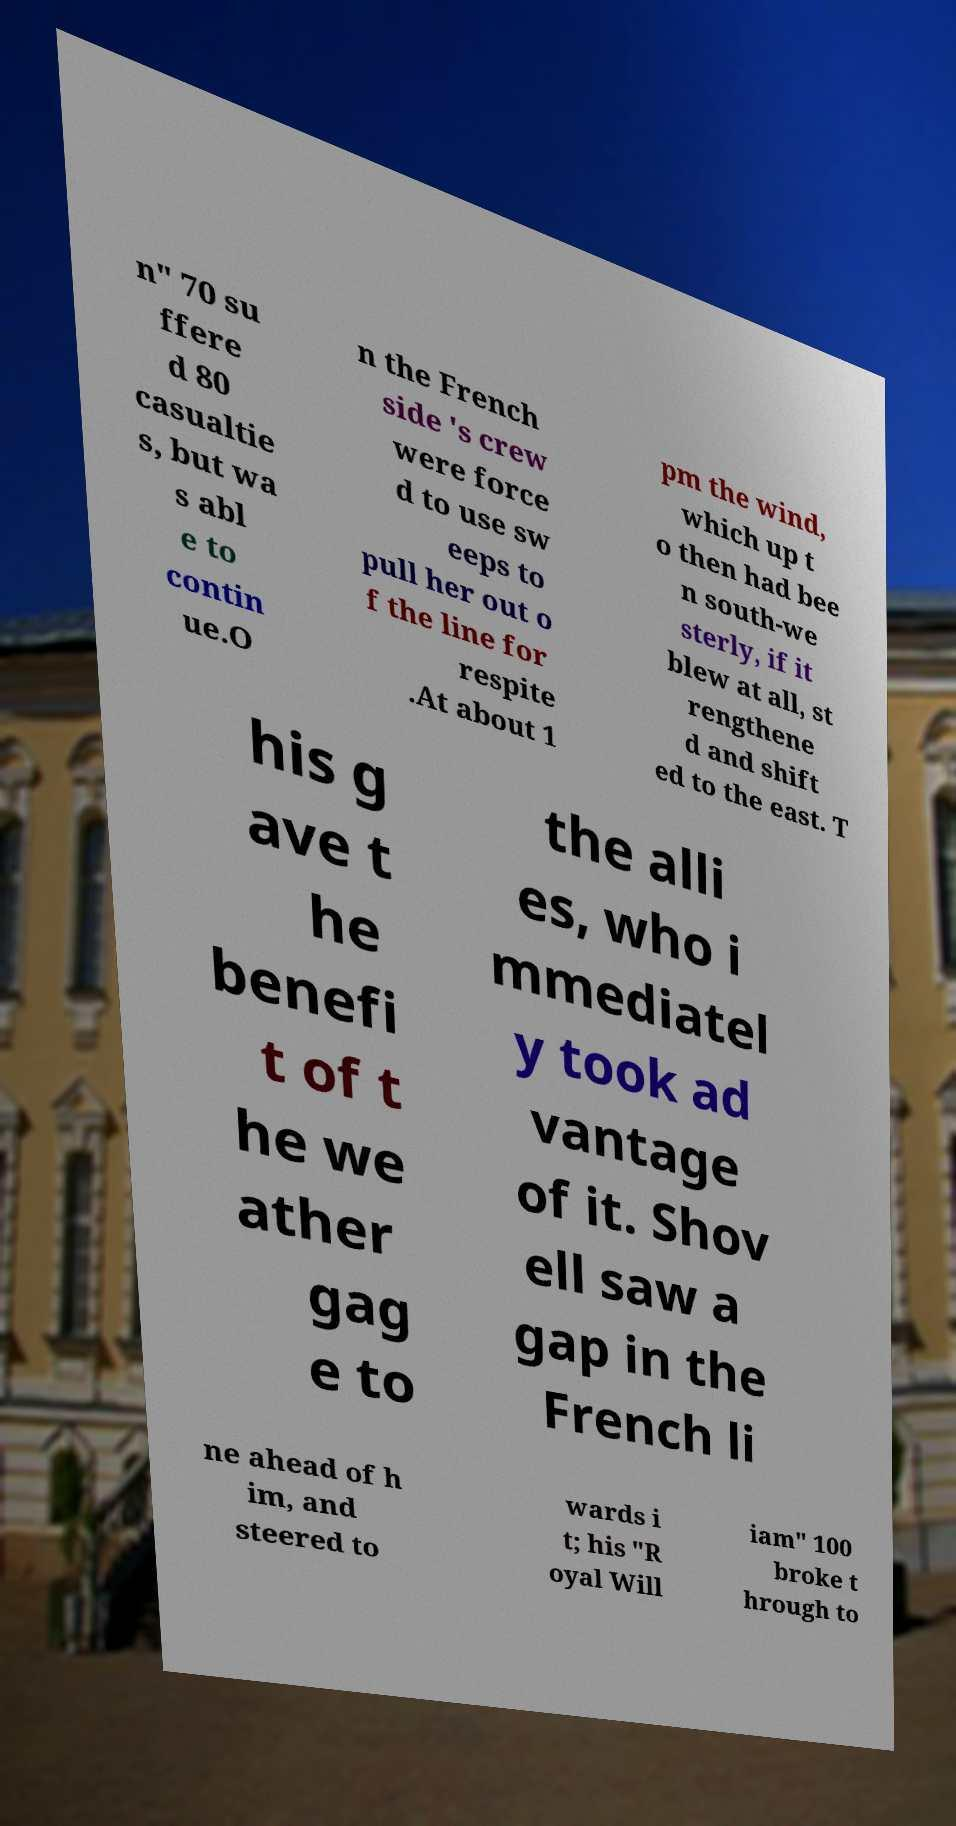Can you accurately transcribe the text from the provided image for me? n" 70 su ffere d 80 casualtie s, but wa s abl e to contin ue.O n the French side 's crew were force d to use sw eeps to pull her out o f the line for respite .At about 1 pm the wind, which up t o then had bee n south-we sterly, if it blew at all, st rengthene d and shift ed to the east. T his g ave t he benefi t of t he we ather gag e to the alli es, who i mmediatel y took ad vantage of it. Shov ell saw a gap in the French li ne ahead of h im, and steered to wards i t; his "R oyal Will iam" 100 broke t hrough to 